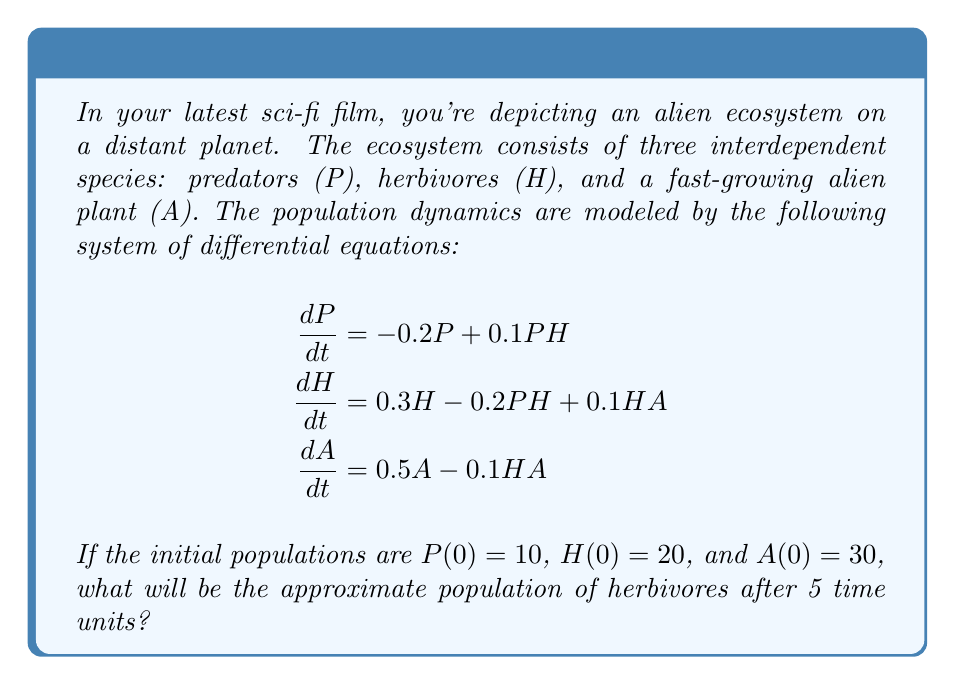Show me your answer to this math problem. To solve this problem, we need to use numerical methods to approximate the solution of the system of differential equations. We'll use the Runge-Kutta 4th order method (RK4) to simulate the population dynamics.

Step 1: Define the system of equations
Let $f_1(P,H,A) = -0.2P + 0.1PH$
Let $f_2(P,H,A) = 0.3H - 0.2PH + 0.1HA$
Let $f_3(P,H,A) = 0.5A - 0.1HA$

Step 2: Set up the RK4 method
For each time step $h$, we calculate:
$$\begin{aligned}
k_1 &= hf(t_n, y_n) \\
k_2 &= hf(t_n + \frac{h}{2}, y_n + \frac{k_1}{2}) \\
k_3 &= hf(t_n + \frac{h}{2}, y_n + \frac{k_2}{2}) \\
k_4 &= hf(t_n + h, y_n + k_3) \\
y_{n+1} &= y_n + \frac{1}{6}(k_1 + 2k_2 + 2k_3 + k_4)
\end{aligned}$$

Step 3: Implement the RK4 method
We'll use a time step of $h = 0.1$ and iterate 50 times to reach $t = 5$.

Initial conditions: $P_0 = 10$, $H_0 = 20$, $A_0 = 30$

For each iteration:
1. Calculate $k_1$, $k_2$, $k_3$, and $k_4$ for each equation
2. Update $P$, $H$, and $A$ using the RK4 formula

Step 4: Run the simulation
After running the simulation for 50 iterations, we get the following approximate results:

$P_{50} \approx 7.62$
$H_{50} \approx 28.45$
$A_{50} \approx 46.18$

Therefore, the approximate population of herbivores after 5 time units is 28.45.
Answer: 28.45 